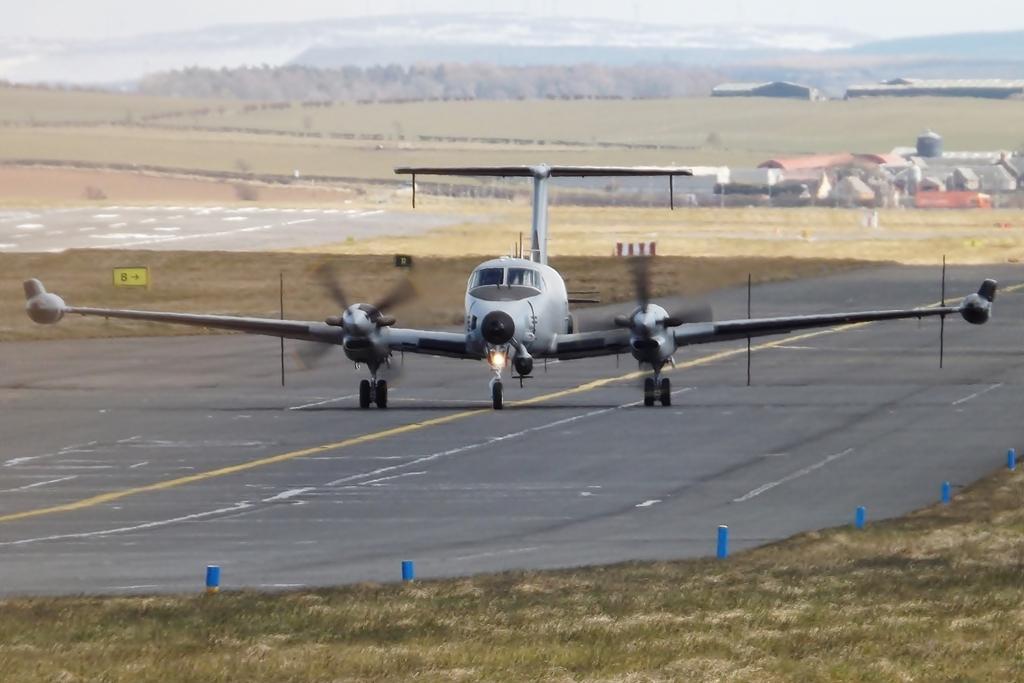Could you give a brief overview of what you see in this image? In this image, in the middle, we can see an airplane which is moving on the road. On the right side, we can see some buildings. On the left side, we can also see a grass. In the background, we can see some trees, building, mountains. At the top, we can see a sky, at the bottom, we can see a grass and a road. 